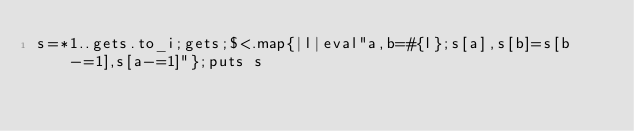<code> <loc_0><loc_0><loc_500><loc_500><_Ruby_>s=*1..gets.to_i;gets;$<.map{|l|eval"a,b=#{l};s[a],s[b]=s[b-=1],s[a-=1]"};puts s</code> 